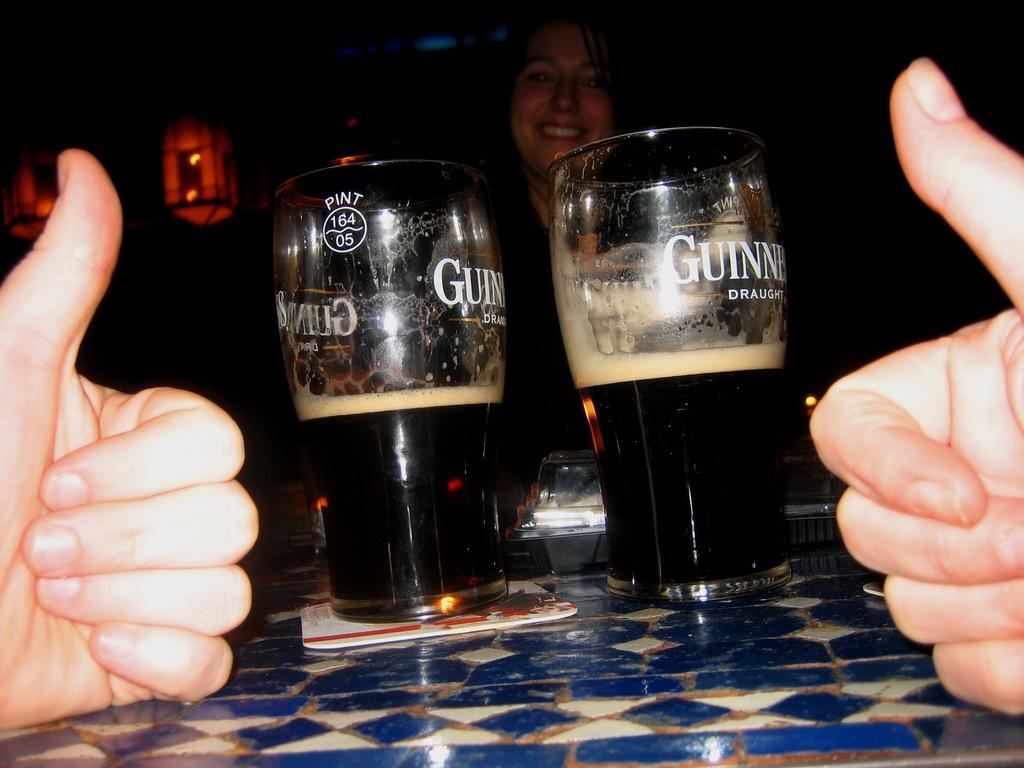How many are drinking guinness?
Keep it short and to the point. 2. What is written on the cup?
Your answer should be very brief. Guinness. 